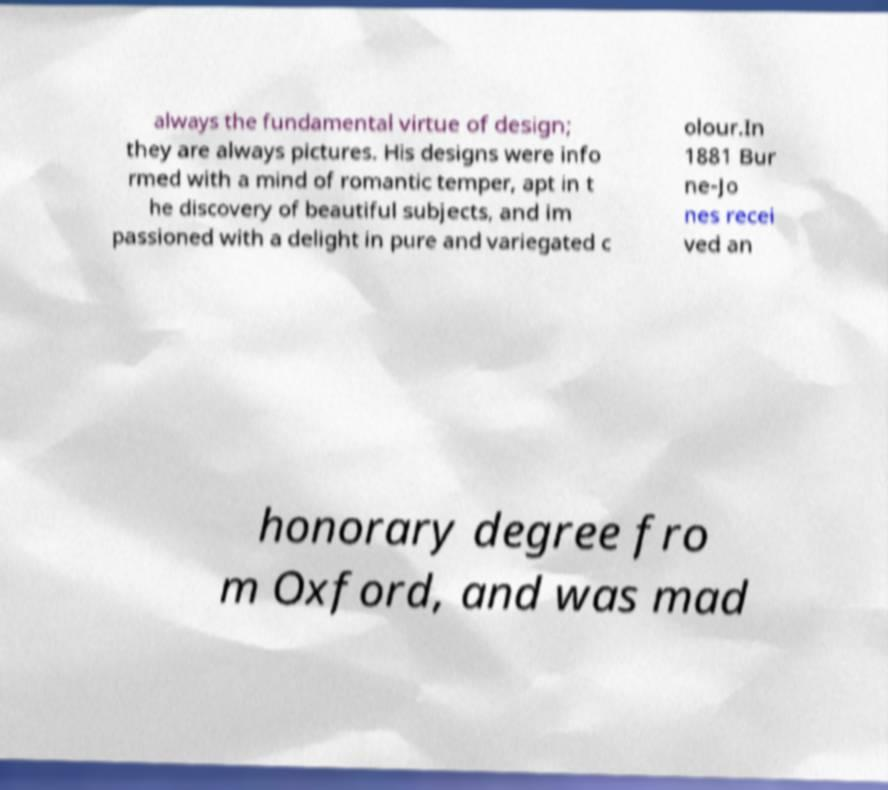I need the written content from this picture converted into text. Can you do that? always the fundamental virtue of design; they are always pictures. His designs were info rmed with a mind of romantic temper, apt in t he discovery of beautiful subjects, and im passioned with a delight in pure and variegated c olour.In 1881 Bur ne-Jo nes recei ved an honorary degree fro m Oxford, and was mad 